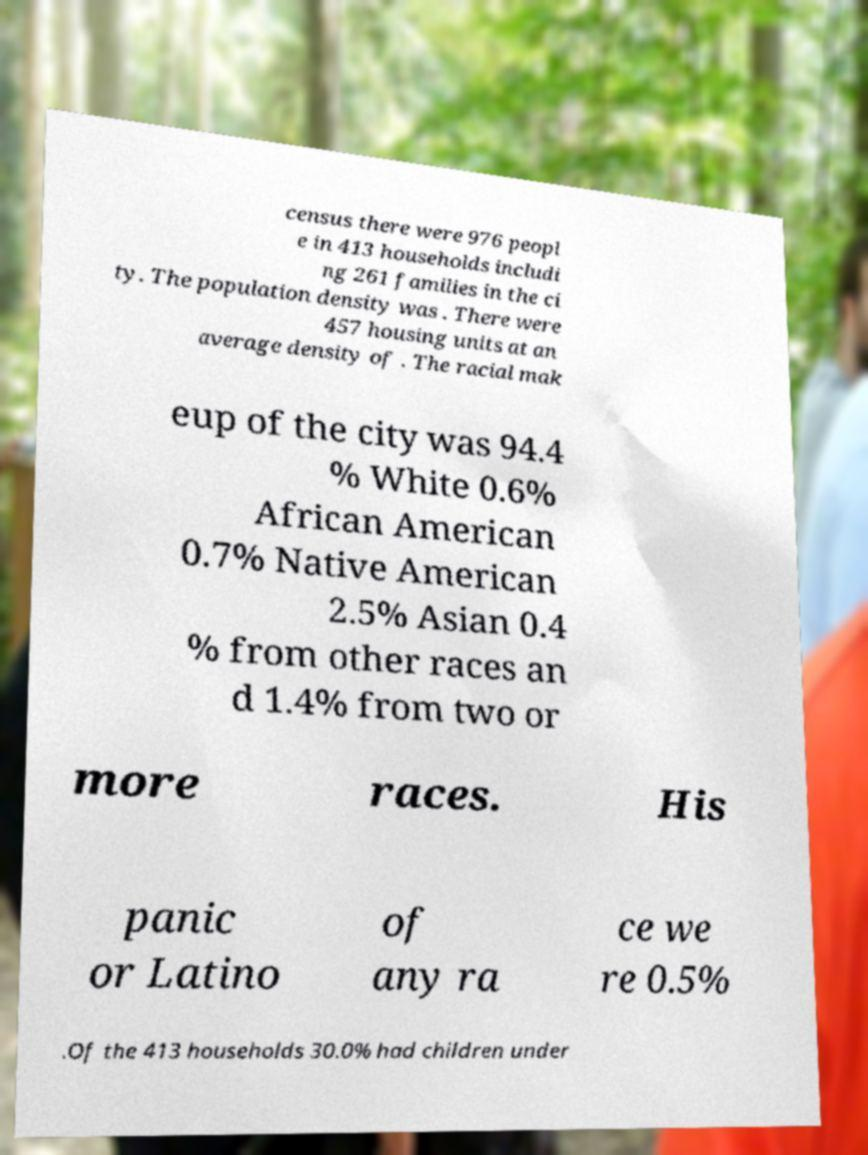Could you assist in decoding the text presented in this image and type it out clearly? census there were 976 peopl e in 413 households includi ng 261 families in the ci ty. The population density was . There were 457 housing units at an average density of . The racial mak eup of the city was 94.4 % White 0.6% African American 0.7% Native American 2.5% Asian 0.4 % from other races an d 1.4% from two or more races. His panic or Latino of any ra ce we re 0.5% .Of the 413 households 30.0% had children under 